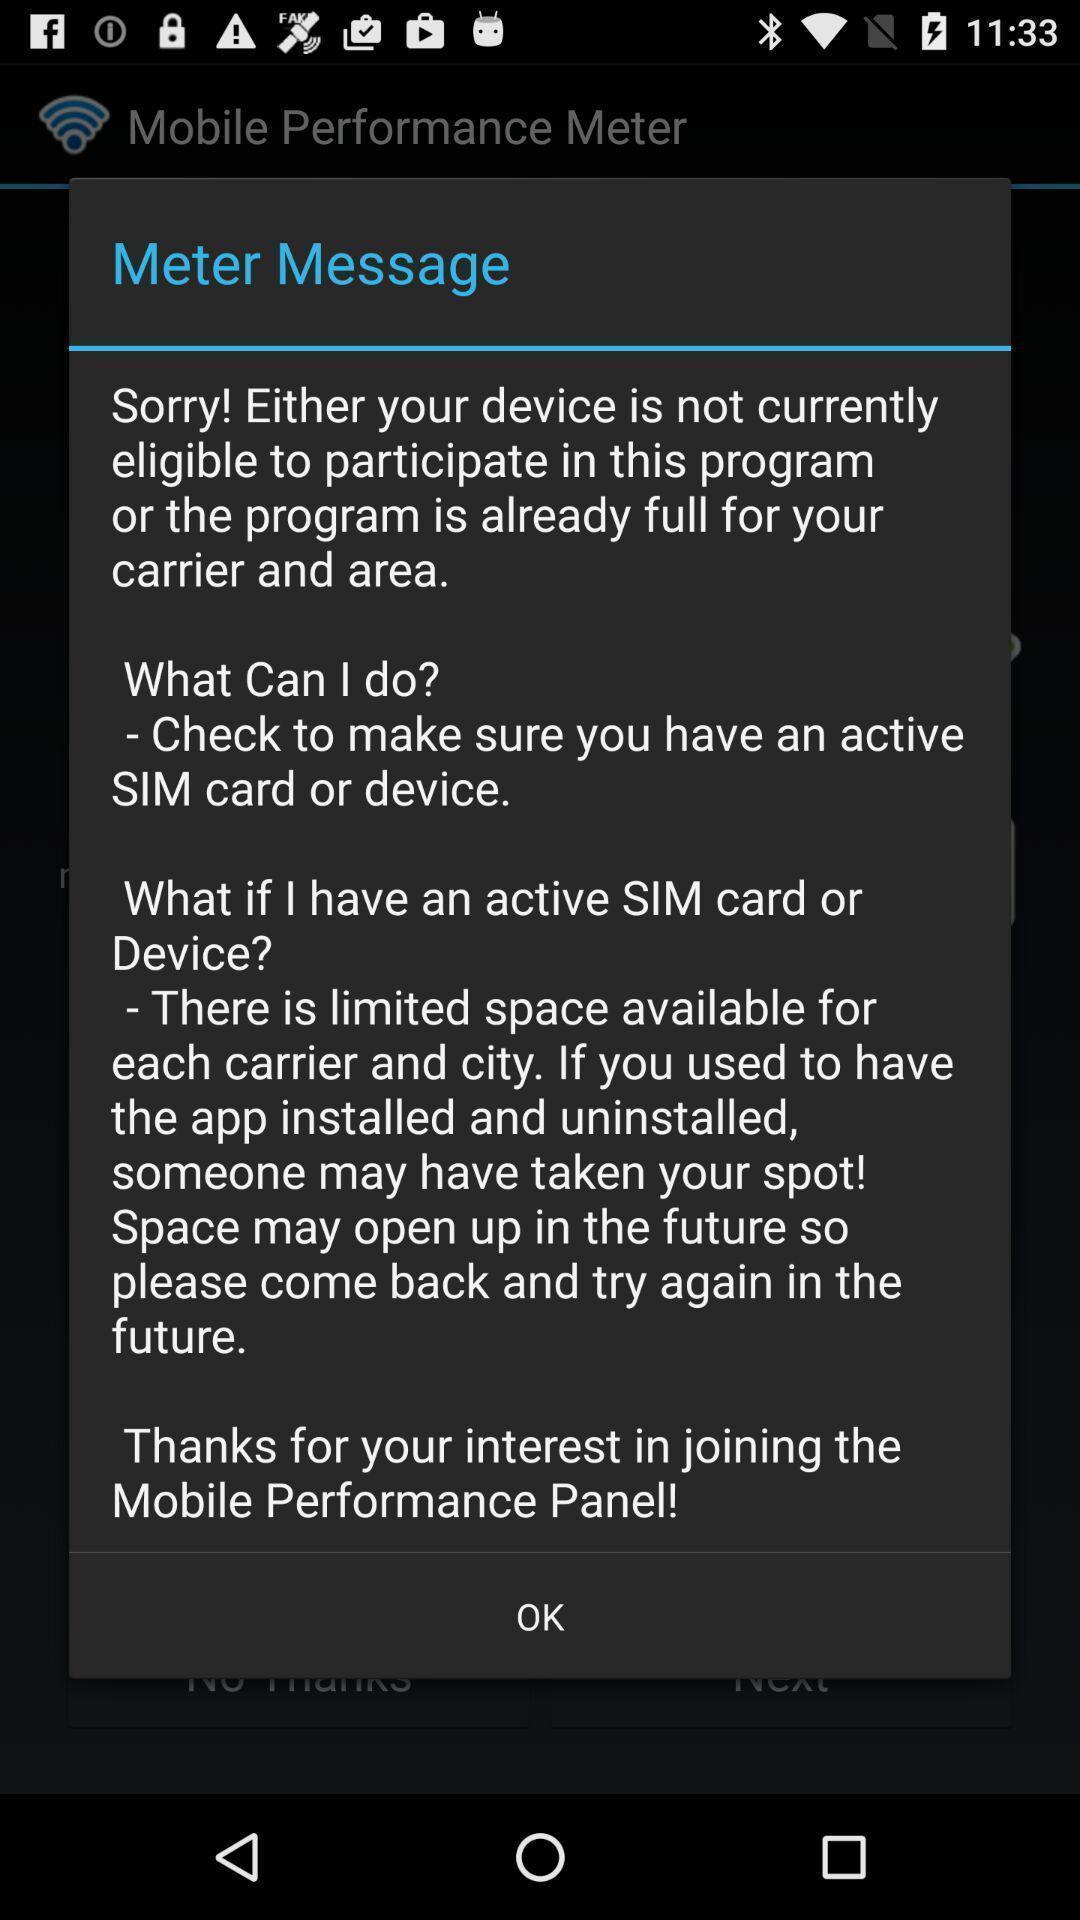What can you discern from this picture? Pop-up giving information for using the application. 